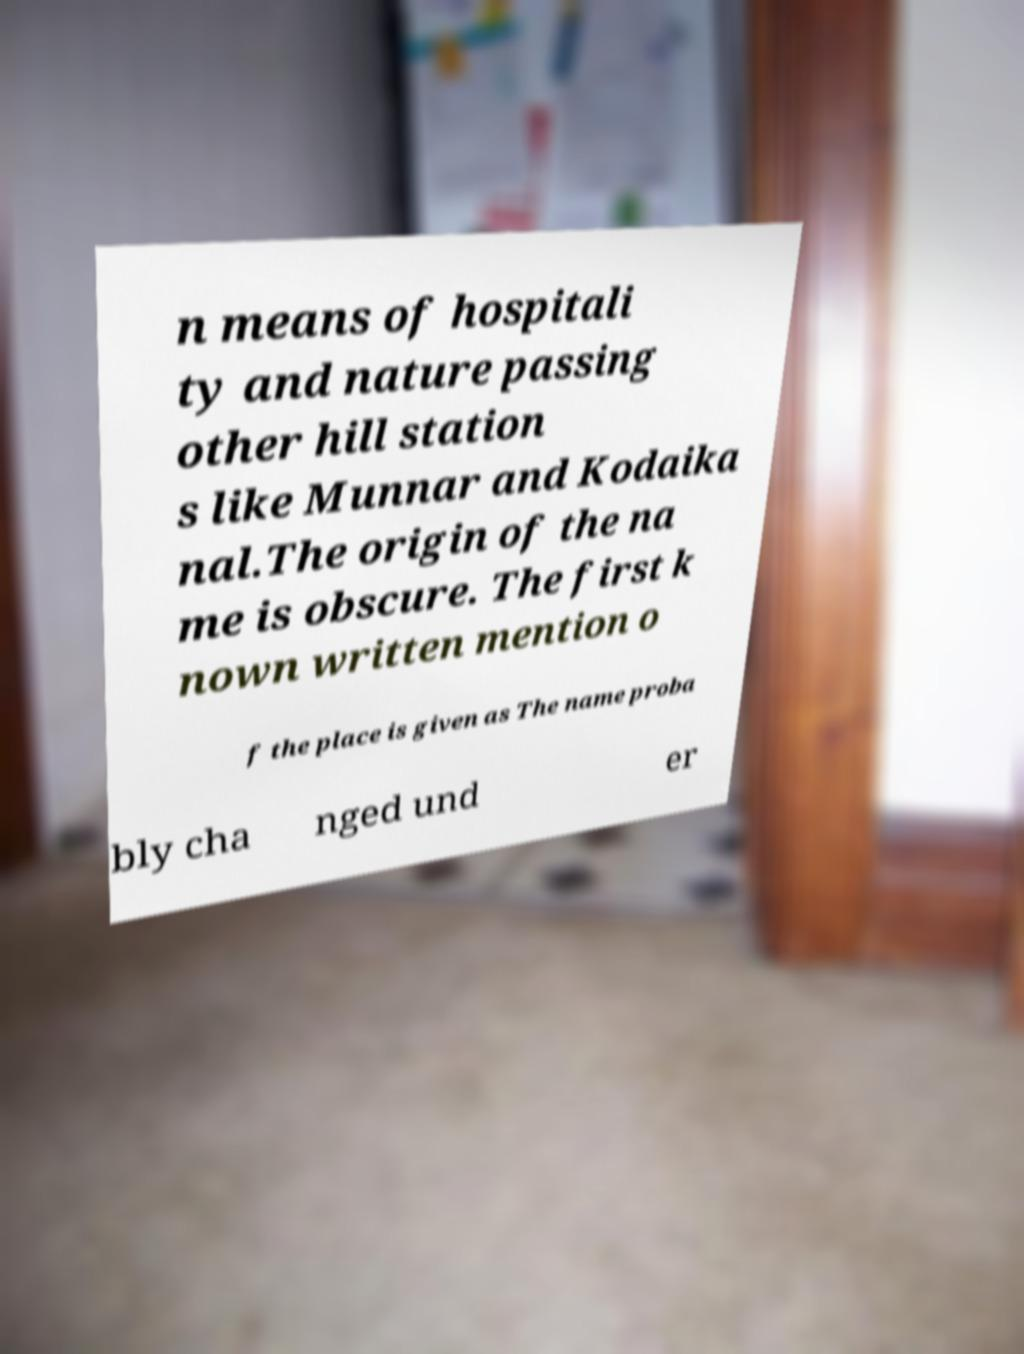There's text embedded in this image that I need extracted. Can you transcribe it verbatim? n means of hospitali ty and nature passing other hill station s like Munnar and Kodaika nal.The origin of the na me is obscure. The first k nown written mention o f the place is given as The name proba bly cha nged und er 